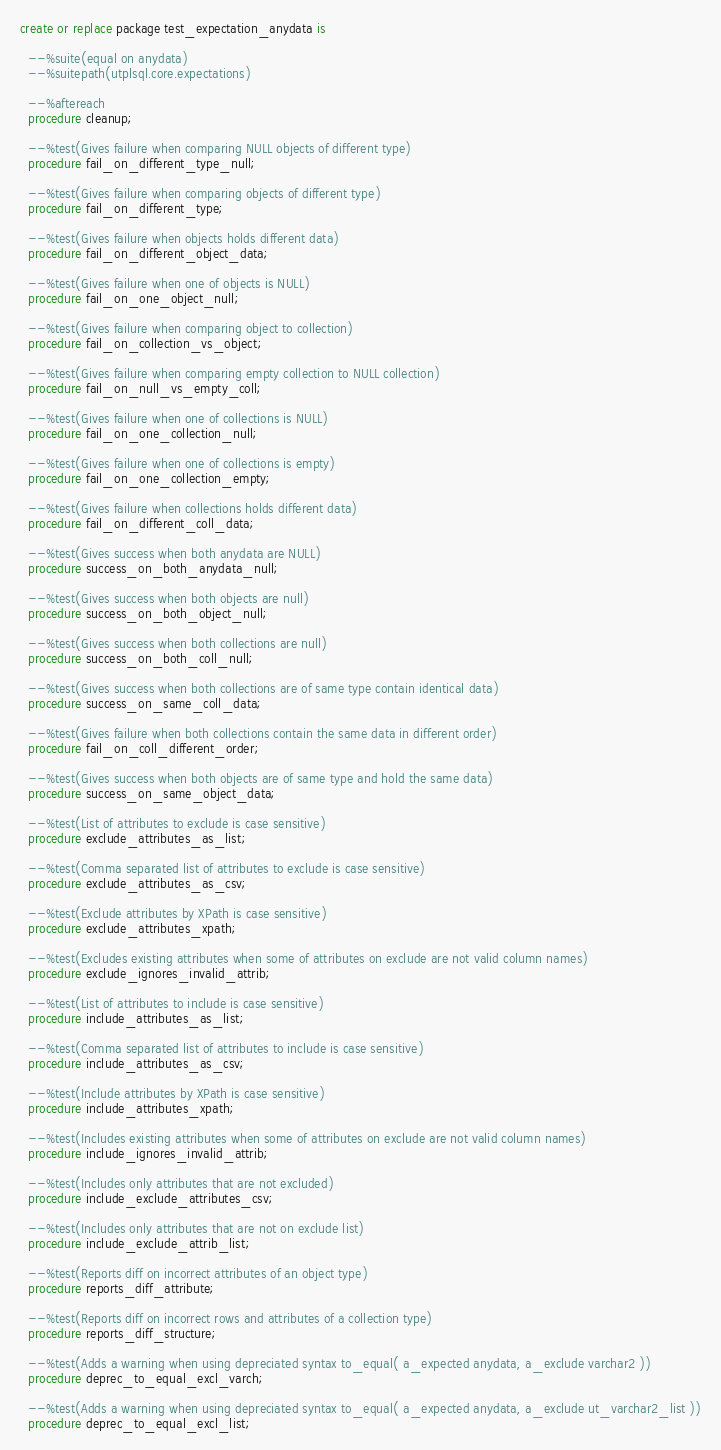<code> <loc_0><loc_0><loc_500><loc_500><_SQL_>create or replace package test_expectation_anydata is

  --%suite(equal on anydata)
  --%suitepath(utplsql.core.expectations)

  --%aftereach
  procedure cleanup;

  --%test(Gives failure when comparing NULL objects of different type)
  procedure fail_on_different_type_null;

  --%test(Gives failure when comparing objects of different type)
  procedure fail_on_different_type;

  --%test(Gives failure when objects holds different data)
  procedure fail_on_different_object_data;

  --%test(Gives failure when one of objects is NULL)
  procedure fail_on_one_object_null;

  --%test(Gives failure when comparing object to collection)
  procedure fail_on_collection_vs_object;

  --%test(Gives failure when comparing empty collection to NULL collection)
  procedure fail_on_null_vs_empty_coll;

  --%test(Gives failure when one of collections is NULL)
  procedure fail_on_one_collection_null;

  --%test(Gives failure when one of collections is empty)
  procedure fail_on_one_collection_empty;

  --%test(Gives failure when collections holds different data)
  procedure fail_on_different_coll_data;

  --%test(Gives success when both anydata are NULL)
  procedure success_on_both_anydata_null;

  --%test(Gives success when both objects are null)
  procedure success_on_both_object_null;

  --%test(Gives success when both collections are null)
  procedure success_on_both_coll_null;

  --%test(Gives success when both collections are of same type contain identical data)
  procedure success_on_same_coll_data;

  --%test(Gives failure when both collections contain the same data in different order)
  procedure fail_on_coll_different_order;

  --%test(Gives success when both objects are of same type and hold the same data)
  procedure success_on_same_object_data;

  --%test(List of attributes to exclude is case sensitive)
  procedure exclude_attributes_as_list;

  --%test(Comma separated list of attributes to exclude is case sensitive)
  procedure exclude_attributes_as_csv;

  --%test(Exclude attributes by XPath is case sensitive)
  procedure exclude_attributes_xpath;

  --%test(Excludes existing attributes when some of attributes on exclude are not valid column names)
  procedure exclude_ignores_invalid_attrib;

  --%test(List of attributes to include is case sensitive)
  procedure include_attributes_as_list;

  --%test(Comma separated list of attributes to include is case sensitive)
  procedure include_attributes_as_csv;

  --%test(Include attributes by XPath is case sensitive)
  procedure include_attributes_xpath;

  --%test(Includes existing attributes when some of attributes on exclude are not valid column names)
  procedure include_ignores_invalid_attrib;

  --%test(Includes only attributes that are not excluded)
  procedure include_exclude_attributes_csv;

  --%test(Includes only attributes that are not on exclude list)
  procedure include_exclude_attrib_list;

  --%test(Reports diff on incorrect attributes of an object type)
  procedure reports_diff_attribute;

  --%test(Reports diff on incorrect rows and attributes of a collection type)
  procedure reports_diff_structure;

  --%test(Adds a warning when using depreciated syntax to_equal( a_expected anydata, a_exclude varchar2 ))
  procedure deprec_to_equal_excl_varch;

  --%test(Adds a warning when using depreciated syntax to_equal( a_expected anydata, a_exclude ut_varchar2_list ))
  procedure deprec_to_equal_excl_list;
</code> 